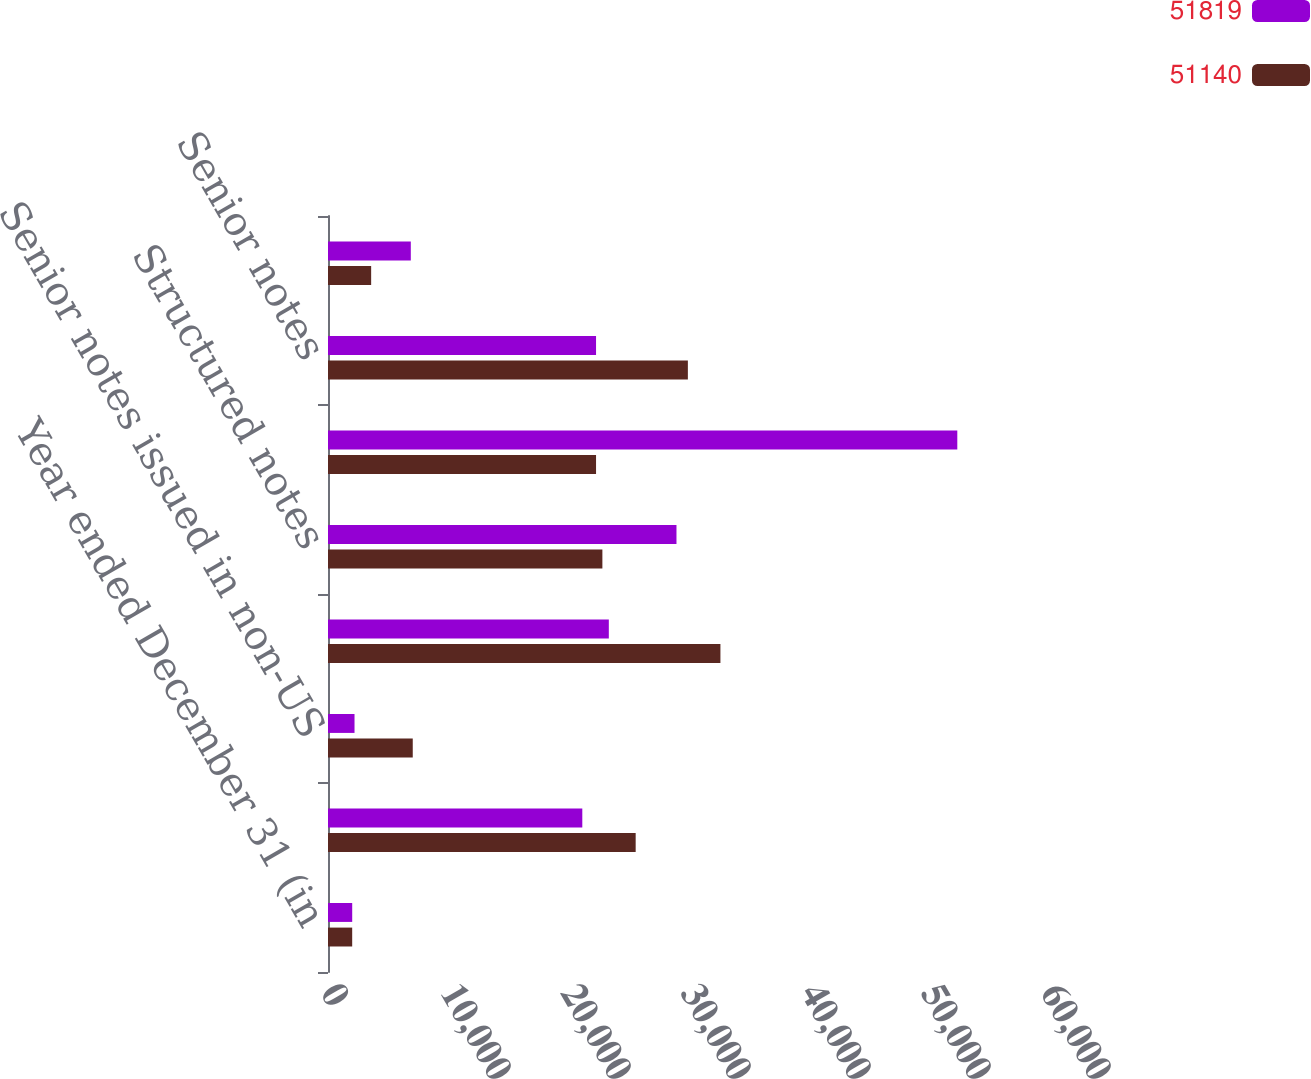Convert chart. <chart><loc_0><loc_0><loc_500><loc_500><stacked_bar_chart><ecel><fcel>Year ended December 31 (in<fcel>Senior notes issued in the US<fcel>Senior notes issued in non-US<fcel>Total senior notes<fcel>Structured notes<fcel>Total long-term unsecured<fcel>Senior notes<fcel>Subordinated debt<nl><fcel>51819<fcel>2017<fcel>21192<fcel>2210<fcel>23402<fcel>29040<fcel>52442<fcel>22337<fcel>6901<nl><fcel>51140<fcel>2016<fcel>25639<fcel>7063<fcel>32702<fcel>22865<fcel>22337<fcel>29989<fcel>3596<nl></chart> 